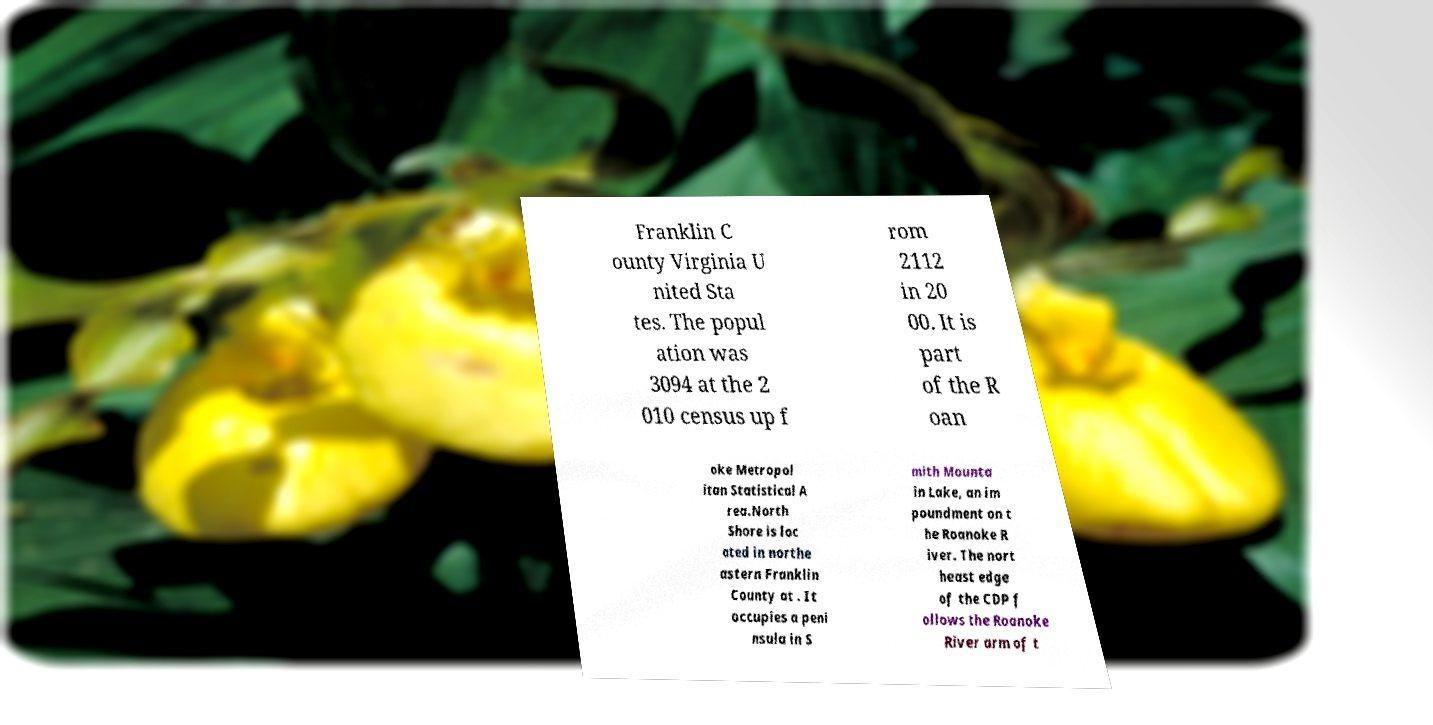Please identify and transcribe the text found in this image. Franklin C ounty Virginia U nited Sta tes. The popul ation was 3094 at the 2 010 census up f rom 2112 in 20 00. It is part of the R oan oke Metropol itan Statistical A rea.North Shore is loc ated in northe astern Franklin County at . It occupies a peni nsula in S mith Mounta in Lake, an im poundment on t he Roanoke R iver. The nort heast edge of the CDP f ollows the Roanoke River arm of t 